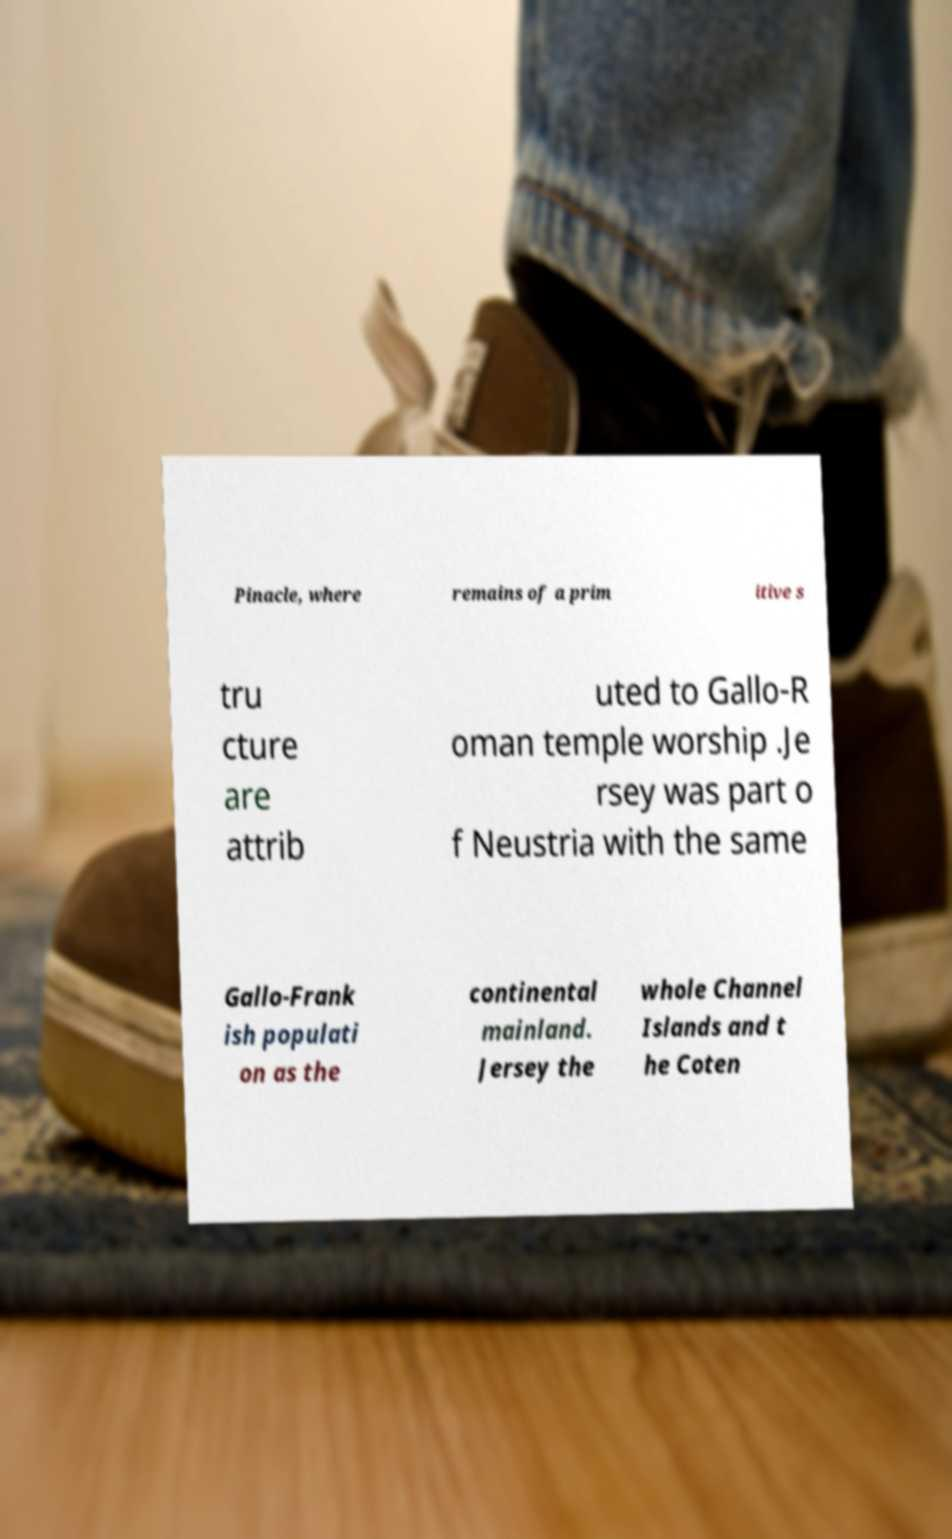For documentation purposes, I need the text within this image transcribed. Could you provide that? Pinacle, where remains of a prim itive s tru cture are attrib uted to Gallo-R oman temple worship .Je rsey was part o f Neustria with the same Gallo-Frank ish populati on as the continental mainland. Jersey the whole Channel Islands and t he Coten 